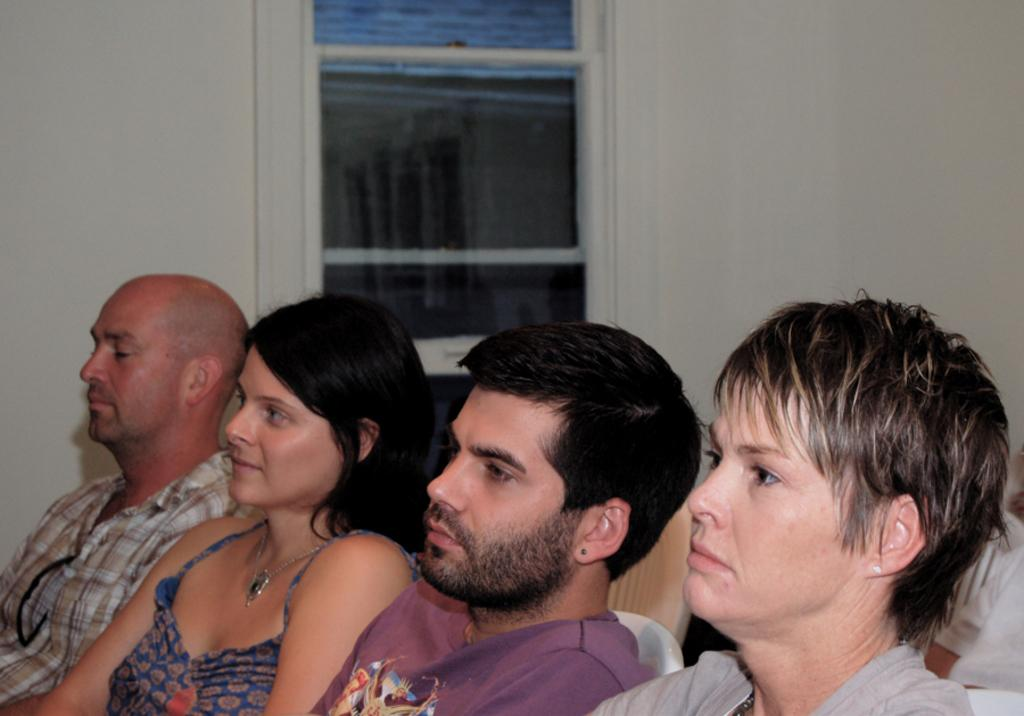Who or what can be seen in the image? There are people in the image. What can be seen in the background of the image? There is a wall and a window in the background of the image. What type of grass is growing in the stomach of the person in the image? There is no grass or stomach visible in the image; it only features people and a wall with a window in the background. 